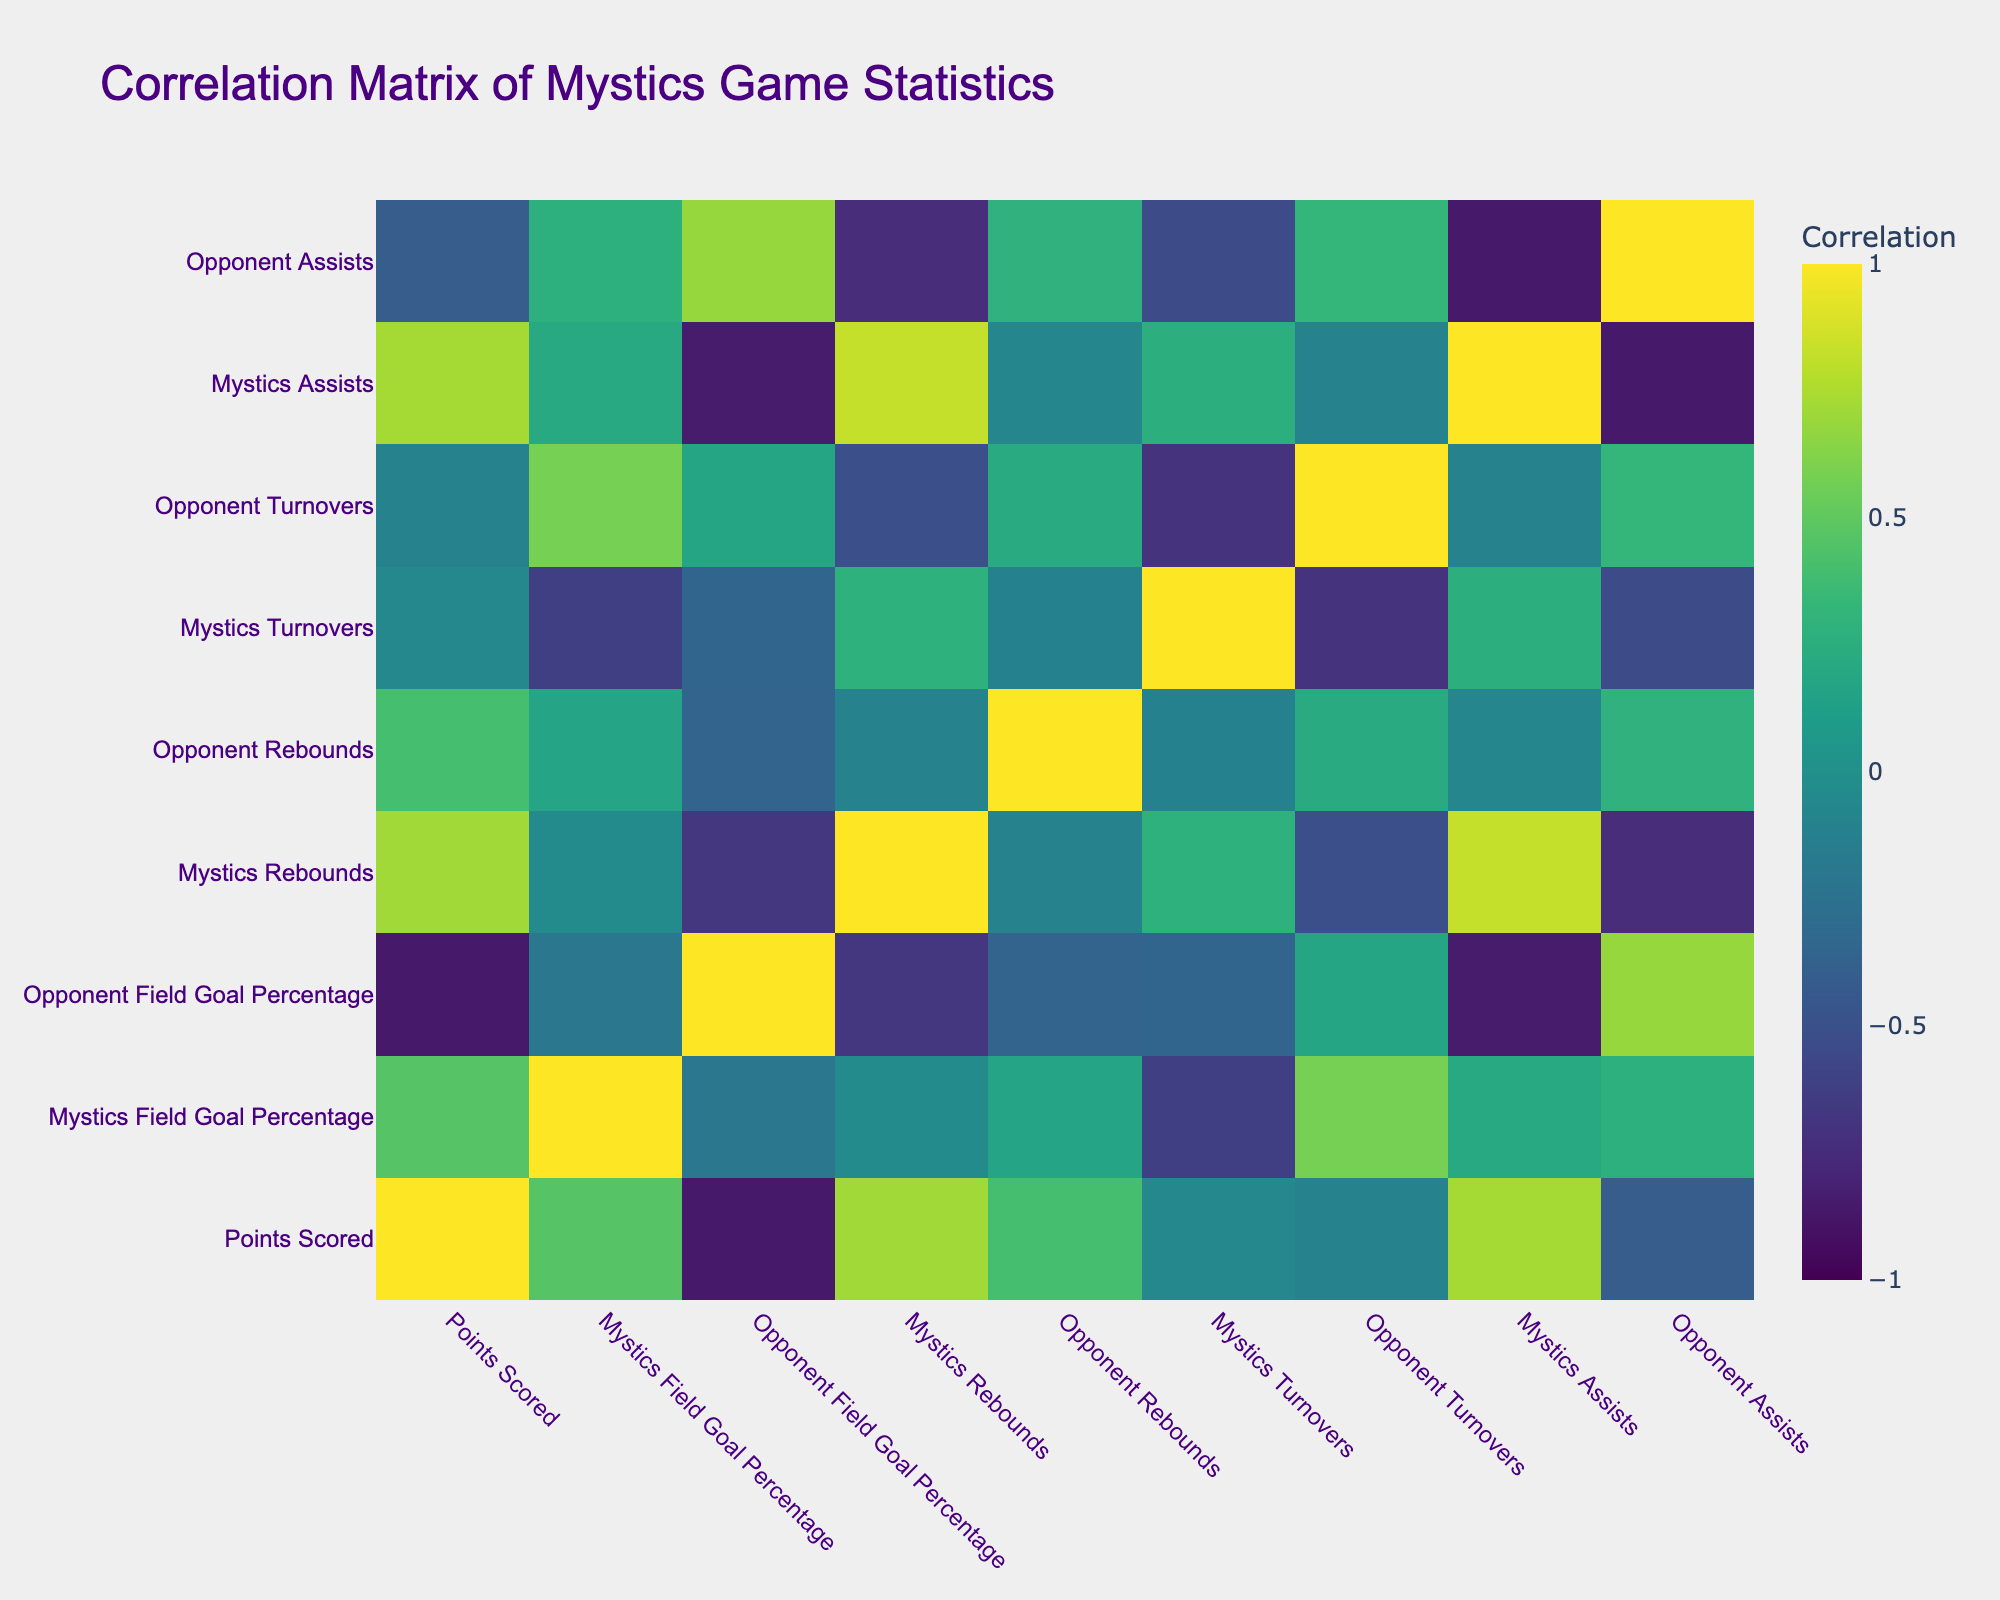What is the highest points scored by the Mystics in a game? The table shows that the highest points scored by the Mystics is 90, achieved against the Seattle Storm on May 29.
Answer: 90 What was the field goal percentage of the Mystics in their game against the Atlanta Dream? According to the table, the Mystics field goal percentage against the Atlanta Dream on June 12 was 45.6%.
Answer: 45.6% What is the average rebounds by the Mystics across all games listed? To find the average, sum the rebounds (34 + 36 + 38 + 30 + 34 + 32 + 33) which equals 237, and divide by 7 (the number of games), resulting in an average of 33.86.
Answer: 33.86 Did the Mystics have more turnovers than their opponents against the Chicago Sky? In the game against the Chicago Sky, the Mystics had 12 turnovers while the opponents had 15 turnovers, indicating that the Mystics had fewer turnovers.
Answer: No Which opponent had the lowest field goal percentage against the Mystics? Looking at the opponent field goal percentages, the Seattle Storm had the lowest at 37.8% in the game on May 29.
Answer: Seattle Storm What is the relationship between points scored and turnovers made by the Mystics? By observing the table, as the points scored by the Mystics increase, the turnovers also vary. For example, in the game against Seattle Storm, the Mystics scored 90 points but had 18 turnovers. This indicates a possible positive correlation in certain games but does not provide a definitive relationship across all games.
Answer: Varying correlation How many total assists did the Mystics record across all games? Summing the assists gives us 20 + 22 + 24 + 18 + 21 + 19 + 23 = 147 total assists over the seven games.
Answer: 147 Was the win-loss record favorable when the Mystics scored above 85 points? Referencing the table, the Mystics scored above 85 points in three games (85, 90, and 88) and won all three matches, confirming a favorable win-loss record.
Answer: Yes How many rebounds did the opponents average per game? To find the average rebounds by opponents, sum the opponent rebounds (30 + 28 + 32 + 35 + 31 + 25 + 29) which totals 210, then divide by 7 games to get an average of 30.
Answer: 30 